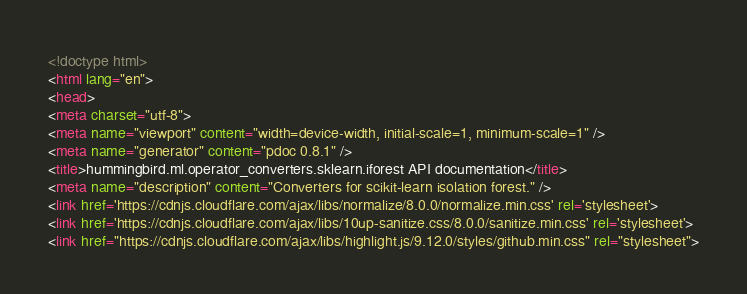Convert code to text. <code><loc_0><loc_0><loc_500><loc_500><_HTML_><!doctype html>
<html lang="en">
<head>
<meta charset="utf-8">
<meta name="viewport" content="width=device-width, initial-scale=1, minimum-scale=1" />
<meta name="generator" content="pdoc 0.8.1" />
<title>hummingbird.ml.operator_converters.sklearn.iforest API documentation</title>
<meta name="description" content="Converters for scikit-learn isolation forest." />
<link href='https://cdnjs.cloudflare.com/ajax/libs/normalize/8.0.0/normalize.min.css' rel='stylesheet'>
<link href='https://cdnjs.cloudflare.com/ajax/libs/10up-sanitize.css/8.0.0/sanitize.min.css' rel='stylesheet'>
<link href="https://cdnjs.cloudflare.com/ajax/libs/highlight.js/9.12.0/styles/github.min.css" rel="stylesheet"></code> 